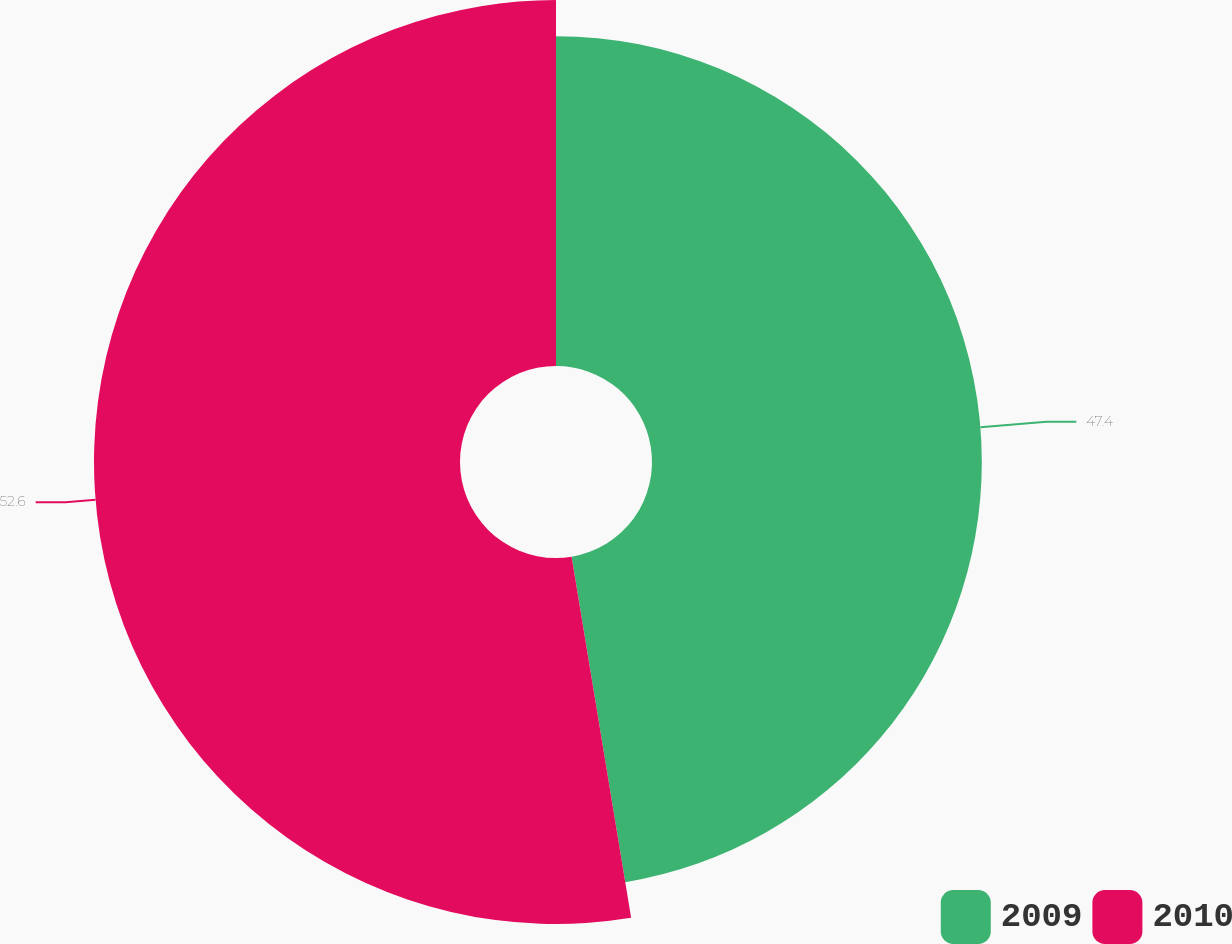Convert chart. <chart><loc_0><loc_0><loc_500><loc_500><pie_chart><fcel>2009<fcel>2010<nl><fcel>47.4%<fcel>52.6%<nl></chart> 